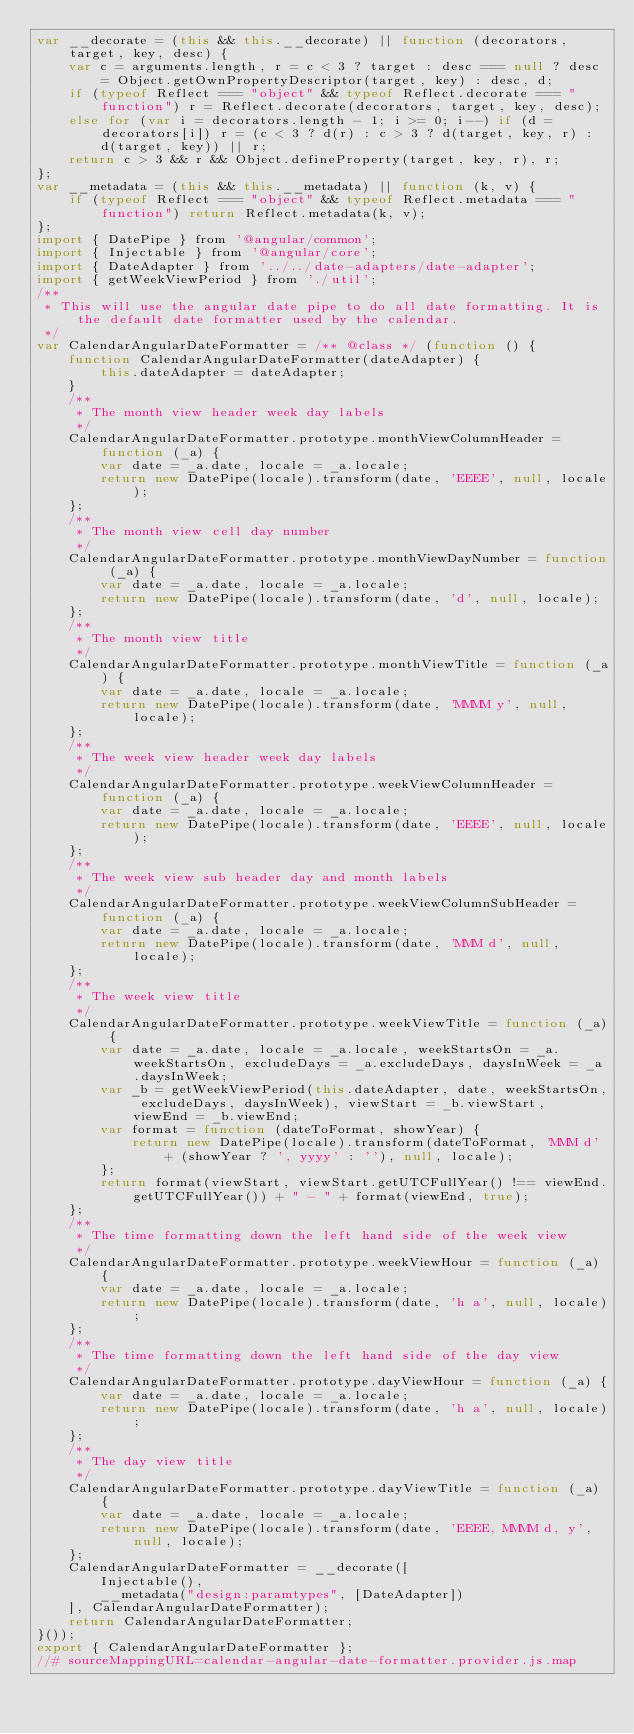Convert code to text. <code><loc_0><loc_0><loc_500><loc_500><_JavaScript_>var __decorate = (this && this.__decorate) || function (decorators, target, key, desc) {
    var c = arguments.length, r = c < 3 ? target : desc === null ? desc = Object.getOwnPropertyDescriptor(target, key) : desc, d;
    if (typeof Reflect === "object" && typeof Reflect.decorate === "function") r = Reflect.decorate(decorators, target, key, desc);
    else for (var i = decorators.length - 1; i >= 0; i--) if (d = decorators[i]) r = (c < 3 ? d(r) : c > 3 ? d(target, key, r) : d(target, key)) || r;
    return c > 3 && r && Object.defineProperty(target, key, r), r;
};
var __metadata = (this && this.__metadata) || function (k, v) {
    if (typeof Reflect === "object" && typeof Reflect.metadata === "function") return Reflect.metadata(k, v);
};
import { DatePipe } from '@angular/common';
import { Injectable } from '@angular/core';
import { DateAdapter } from '../../date-adapters/date-adapter';
import { getWeekViewPeriod } from './util';
/**
 * This will use the angular date pipe to do all date formatting. It is the default date formatter used by the calendar.
 */
var CalendarAngularDateFormatter = /** @class */ (function () {
    function CalendarAngularDateFormatter(dateAdapter) {
        this.dateAdapter = dateAdapter;
    }
    /**
     * The month view header week day labels
     */
    CalendarAngularDateFormatter.prototype.monthViewColumnHeader = function (_a) {
        var date = _a.date, locale = _a.locale;
        return new DatePipe(locale).transform(date, 'EEEE', null, locale);
    };
    /**
     * The month view cell day number
     */
    CalendarAngularDateFormatter.prototype.monthViewDayNumber = function (_a) {
        var date = _a.date, locale = _a.locale;
        return new DatePipe(locale).transform(date, 'd', null, locale);
    };
    /**
     * The month view title
     */
    CalendarAngularDateFormatter.prototype.monthViewTitle = function (_a) {
        var date = _a.date, locale = _a.locale;
        return new DatePipe(locale).transform(date, 'MMMM y', null, locale);
    };
    /**
     * The week view header week day labels
     */
    CalendarAngularDateFormatter.prototype.weekViewColumnHeader = function (_a) {
        var date = _a.date, locale = _a.locale;
        return new DatePipe(locale).transform(date, 'EEEE', null, locale);
    };
    /**
     * The week view sub header day and month labels
     */
    CalendarAngularDateFormatter.prototype.weekViewColumnSubHeader = function (_a) {
        var date = _a.date, locale = _a.locale;
        return new DatePipe(locale).transform(date, 'MMM d', null, locale);
    };
    /**
     * The week view title
     */
    CalendarAngularDateFormatter.prototype.weekViewTitle = function (_a) {
        var date = _a.date, locale = _a.locale, weekStartsOn = _a.weekStartsOn, excludeDays = _a.excludeDays, daysInWeek = _a.daysInWeek;
        var _b = getWeekViewPeriod(this.dateAdapter, date, weekStartsOn, excludeDays, daysInWeek), viewStart = _b.viewStart, viewEnd = _b.viewEnd;
        var format = function (dateToFormat, showYear) {
            return new DatePipe(locale).transform(dateToFormat, 'MMM d' + (showYear ? ', yyyy' : ''), null, locale);
        };
        return format(viewStart, viewStart.getUTCFullYear() !== viewEnd.getUTCFullYear()) + " - " + format(viewEnd, true);
    };
    /**
     * The time formatting down the left hand side of the week view
     */
    CalendarAngularDateFormatter.prototype.weekViewHour = function (_a) {
        var date = _a.date, locale = _a.locale;
        return new DatePipe(locale).transform(date, 'h a', null, locale);
    };
    /**
     * The time formatting down the left hand side of the day view
     */
    CalendarAngularDateFormatter.prototype.dayViewHour = function (_a) {
        var date = _a.date, locale = _a.locale;
        return new DatePipe(locale).transform(date, 'h a', null, locale);
    };
    /**
     * The day view title
     */
    CalendarAngularDateFormatter.prototype.dayViewTitle = function (_a) {
        var date = _a.date, locale = _a.locale;
        return new DatePipe(locale).transform(date, 'EEEE, MMMM d, y', null, locale);
    };
    CalendarAngularDateFormatter = __decorate([
        Injectable(),
        __metadata("design:paramtypes", [DateAdapter])
    ], CalendarAngularDateFormatter);
    return CalendarAngularDateFormatter;
}());
export { CalendarAngularDateFormatter };
//# sourceMappingURL=calendar-angular-date-formatter.provider.js.map</code> 